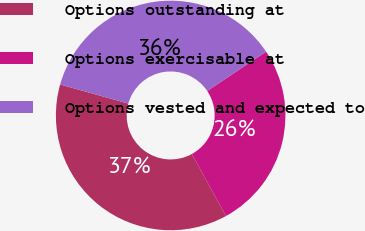Convert chart to OTSL. <chart><loc_0><loc_0><loc_500><loc_500><pie_chart><fcel>Options outstanding at<fcel>Options exercisable at<fcel>Options vested and expected to<nl><fcel>37.35%<fcel>26.38%<fcel>36.26%<nl></chart> 